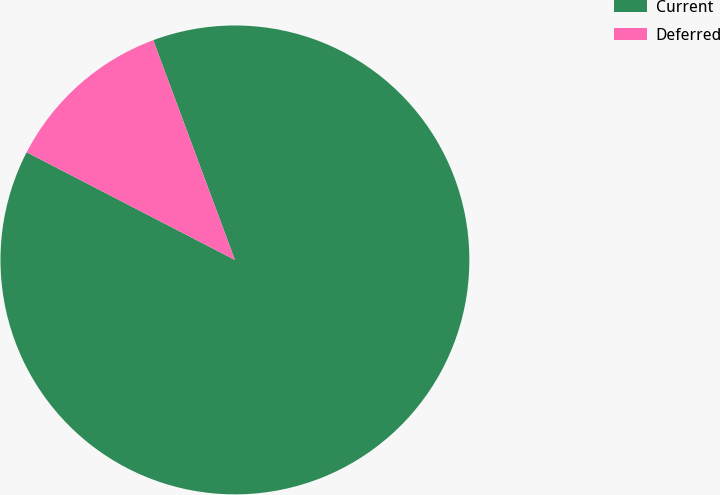Convert chart. <chart><loc_0><loc_0><loc_500><loc_500><pie_chart><fcel>Current<fcel>Deferred<nl><fcel>88.26%<fcel>11.74%<nl></chart> 